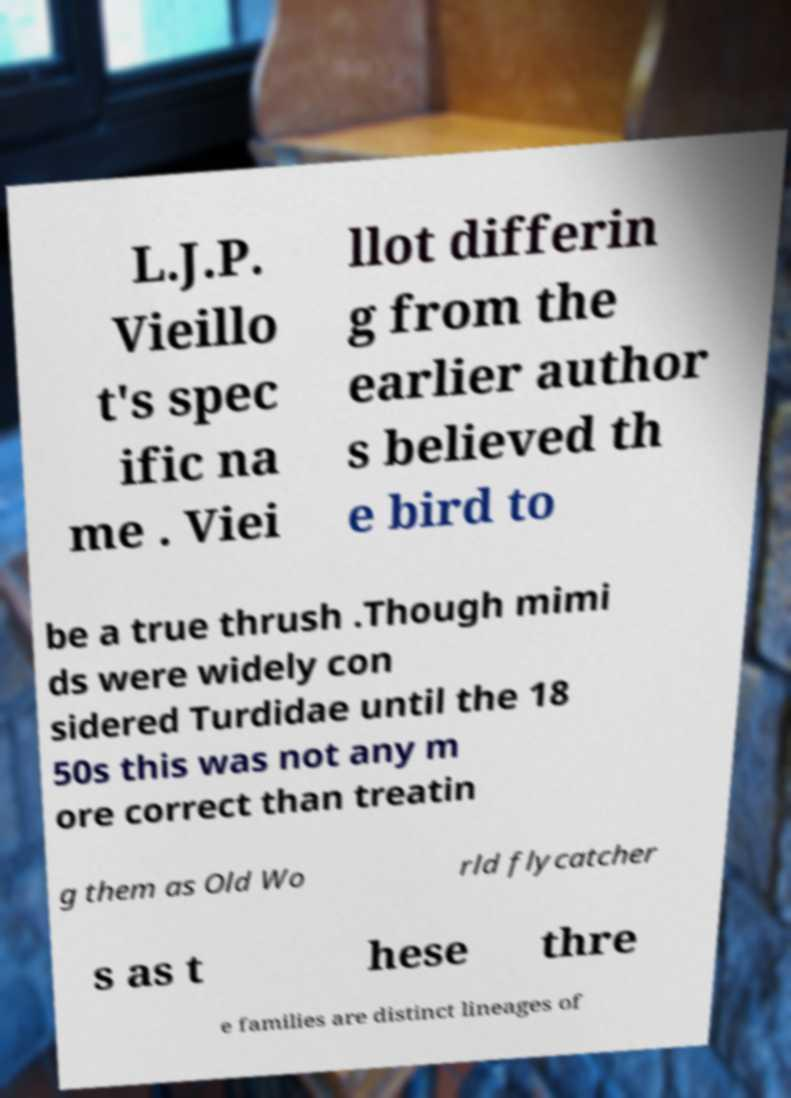What messages or text are displayed in this image? I need them in a readable, typed format. L.J.P. Vieillo t's spec ific na me . Viei llot differin g from the earlier author s believed th e bird to be a true thrush .Though mimi ds were widely con sidered Turdidae until the 18 50s this was not any m ore correct than treatin g them as Old Wo rld flycatcher s as t hese thre e families are distinct lineages of 